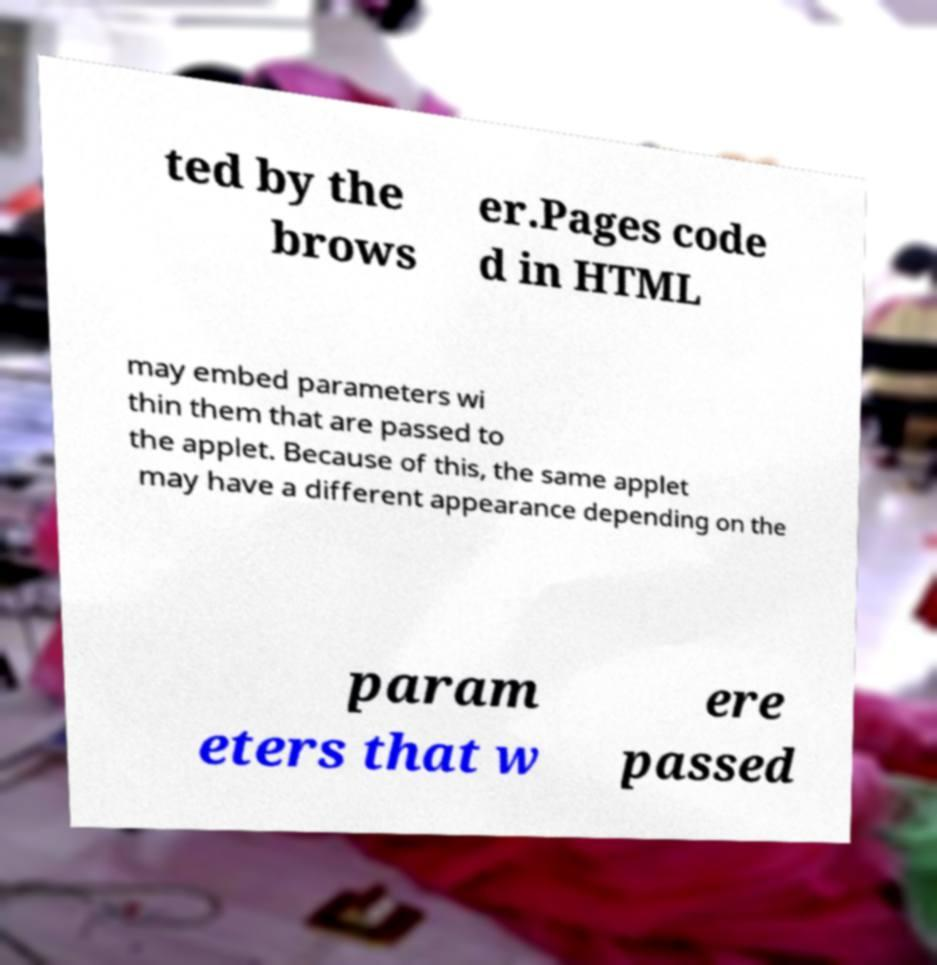I need the written content from this picture converted into text. Can you do that? ted by the brows er.Pages code d in HTML may embed parameters wi thin them that are passed to the applet. Because of this, the same applet may have a different appearance depending on the param eters that w ere passed 